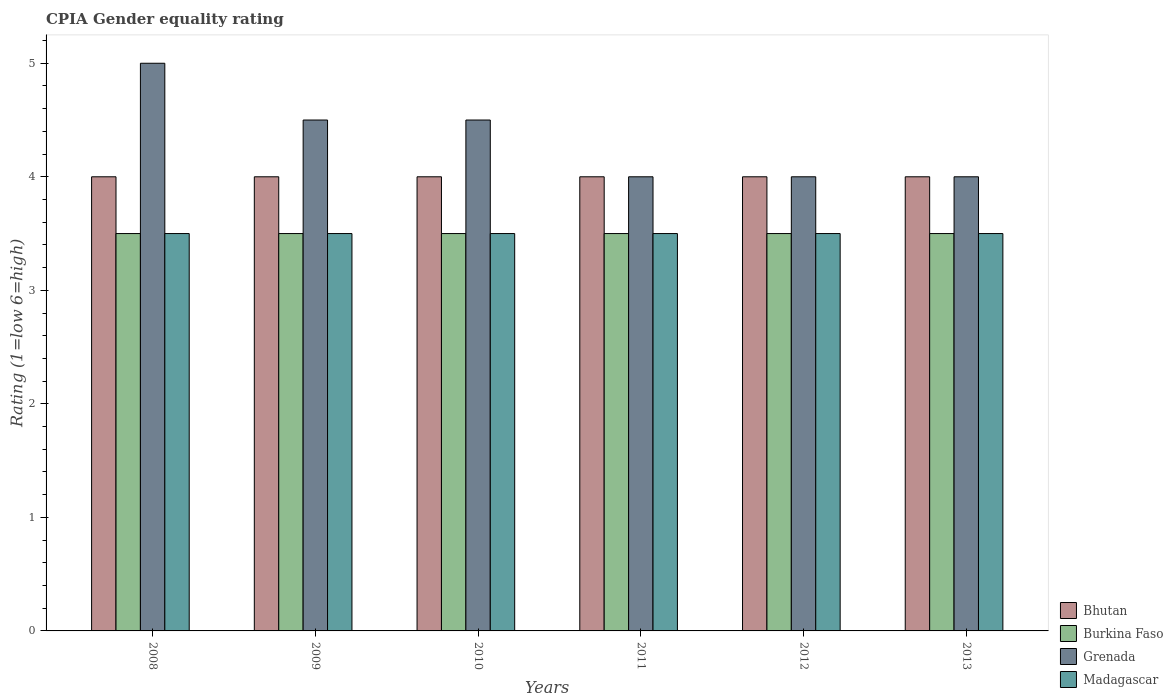Are the number of bars per tick equal to the number of legend labels?
Provide a succinct answer. Yes. Are the number of bars on each tick of the X-axis equal?
Make the answer very short. Yes. How many bars are there on the 2nd tick from the left?
Make the answer very short. 4. How many bars are there on the 3rd tick from the right?
Your response must be concise. 4. Across all years, what is the minimum CPIA rating in Madagascar?
Ensure brevity in your answer.  3.5. What is the difference between the CPIA rating in Grenada in 2008 and that in 2011?
Your response must be concise. 1. What is the average CPIA rating in Grenada per year?
Ensure brevity in your answer.  4.33. In the year 2009, what is the difference between the CPIA rating in Burkina Faso and CPIA rating in Grenada?
Offer a terse response. -1. In how many years, is the CPIA rating in Madagascar greater than 5?
Provide a succinct answer. 0. What is the difference between the highest and the lowest CPIA rating in Grenada?
Provide a short and direct response. 1. Is the sum of the CPIA rating in Madagascar in 2011 and 2013 greater than the maximum CPIA rating in Grenada across all years?
Provide a short and direct response. Yes. Is it the case that in every year, the sum of the CPIA rating in Bhutan and CPIA rating in Grenada is greater than the sum of CPIA rating in Madagascar and CPIA rating in Burkina Faso?
Ensure brevity in your answer.  No. What does the 1st bar from the left in 2008 represents?
Give a very brief answer. Bhutan. What does the 4th bar from the right in 2011 represents?
Keep it short and to the point. Bhutan. Is it the case that in every year, the sum of the CPIA rating in Madagascar and CPIA rating in Bhutan is greater than the CPIA rating in Grenada?
Your answer should be very brief. Yes. What is the title of the graph?
Your answer should be very brief. CPIA Gender equality rating. Does "Tanzania" appear as one of the legend labels in the graph?
Make the answer very short. No. What is the label or title of the X-axis?
Give a very brief answer. Years. What is the Rating (1=low 6=high) of Bhutan in 2008?
Provide a succinct answer. 4. What is the Rating (1=low 6=high) in Burkina Faso in 2008?
Provide a short and direct response. 3.5. What is the Rating (1=low 6=high) of Madagascar in 2008?
Offer a very short reply. 3.5. What is the Rating (1=low 6=high) in Bhutan in 2010?
Provide a succinct answer. 4. What is the Rating (1=low 6=high) in Grenada in 2010?
Your answer should be compact. 4.5. What is the Rating (1=low 6=high) in Grenada in 2011?
Ensure brevity in your answer.  4. What is the Rating (1=low 6=high) of Bhutan in 2013?
Keep it short and to the point. 4. Across all years, what is the maximum Rating (1=low 6=high) in Bhutan?
Provide a short and direct response. 4. Across all years, what is the minimum Rating (1=low 6=high) in Bhutan?
Keep it short and to the point. 4. Across all years, what is the minimum Rating (1=low 6=high) of Madagascar?
Make the answer very short. 3.5. What is the total Rating (1=low 6=high) of Madagascar in the graph?
Your answer should be compact. 21. What is the difference between the Rating (1=low 6=high) of Bhutan in 2008 and that in 2009?
Ensure brevity in your answer.  0. What is the difference between the Rating (1=low 6=high) of Burkina Faso in 2008 and that in 2009?
Your answer should be compact. 0. What is the difference between the Rating (1=low 6=high) of Grenada in 2008 and that in 2009?
Keep it short and to the point. 0.5. What is the difference between the Rating (1=low 6=high) of Madagascar in 2008 and that in 2009?
Your response must be concise. 0. What is the difference between the Rating (1=low 6=high) of Burkina Faso in 2008 and that in 2010?
Offer a terse response. 0. What is the difference between the Rating (1=low 6=high) in Grenada in 2008 and that in 2010?
Provide a short and direct response. 0.5. What is the difference between the Rating (1=low 6=high) in Bhutan in 2008 and that in 2011?
Provide a succinct answer. 0. What is the difference between the Rating (1=low 6=high) of Bhutan in 2008 and that in 2012?
Ensure brevity in your answer.  0. What is the difference between the Rating (1=low 6=high) of Burkina Faso in 2008 and that in 2012?
Provide a succinct answer. 0. What is the difference between the Rating (1=low 6=high) of Grenada in 2008 and that in 2012?
Provide a short and direct response. 1. What is the difference between the Rating (1=low 6=high) of Madagascar in 2008 and that in 2012?
Keep it short and to the point. 0. What is the difference between the Rating (1=low 6=high) in Bhutan in 2009 and that in 2010?
Your answer should be very brief. 0. What is the difference between the Rating (1=low 6=high) of Burkina Faso in 2009 and that in 2010?
Ensure brevity in your answer.  0. What is the difference between the Rating (1=low 6=high) of Madagascar in 2009 and that in 2010?
Your answer should be very brief. 0. What is the difference between the Rating (1=low 6=high) of Burkina Faso in 2009 and that in 2011?
Make the answer very short. 0. What is the difference between the Rating (1=low 6=high) in Grenada in 2009 and that in 2011?
Make the answer very short. 0.5. What is the difference between the Rating (1=low 6=high) in Madagascar in 2009 and that in 2011?
Give a very brief answer. 0. What is the difference between the Rating (1=low 6=high) in Grenada in 2009 and that in 2012?
Make the answer very short. 0.5. What is the difference between the Rating (1=low 6=high) of Madagascar in 2009 and that in 2012?
Make the answer very short. 0. What is the difference between the Rating (1=low 6=high) of Burkina Faso in 2009 and that in 2013?
Offer a very short reply. 0. What is the difference between the Rating (1=low 6=high) in Bhutan in 2010 and that in 2011?
Your answer should be compact. 0. What is the difference between the Rating (1=low 6=high) of Grenada in 2010 and that in 2011?
Provide a short and direct response. 0.5. What is the difference between the Rating (1=low 6=high) of Madagascar in 2010 and that in 2011?
Ensure brevity in your answer.  0. What is the difference between the Rating (1=low 6=high) in Bhutan in 2010 and that in 2012?
Offer a very short reply. 0. What is the difference between the Rating (1=low 6=high) of Grenada in 2010 and that in 2012?
Offer a terse response. 0.5. What is the difference between the Rating (1=low 6=high) in Bhutan in 2010 and that in 2013?
Provide a succinct answer. 0. What is the difference between the Rating (1=low 6=high) in Burkina Faso in 2010 and that in 2013?
Your answer should be very brief. 0. What is the difference between the Rating (1=low 6=high) in Grenada in 2010 and that in 2013?
Ensure brevity in your answer.  0.5. What is the difference between the Rating (1=low 6=high) in Burkina Faso in 2011 and that in 2012?
Your answer should be compact. 0. What is the difference between the Rating (1=low 6=high) of Madagascar in 2011 and that in 2012?
Offer a terse response. 0. What is the difference between the Rating (1=low 6=high) in Burkina Faso in 2011 and that in 2013?
Provide a short and direct response. 0. What is the difference between the Rating (1=low 6=high) of Grenada in 2011 and that in 2013?
Your answer should be compact. 0. What is the difference between the Rating (1=low 6=high) in Madagascar in 2011 and that in 2013?
Your answer should be compact. 0. What is the difference between the Rating (1=low 6=high) of Grenada in 2012 and that in 2013?
Ensure brevity in your answer.  0. What is the difference between the Rating (1=low 6=high) of Bhutan in 2008 and the Rating (1=low 6=high) of Burkina Faso in 2009?
Ensure brevity in your answer.  0.5. What is the difference between the Rating (1=low 6=high) in Bhutan in 2008 and the Rating (1=low 6=high) in Grenada in 2009?
Offer a terse response. -0.5. What is the difference between the Rating (1=low 6=high) in Bhutan in 2008 and the Rating (1=low 6=high) in Madagascar in 2009?
Your response must be concise. 0.5. What is the difference between the Rating (1=low 6=high) of Burkina Faso in 2008 and the Rating (1=low 6=high) of Madagascar in 2009?
Provide a short and direct response. 0. What is the difference between the Rating (1=low 6=high) of Grenada in 2008 and the Rating (1=low 6=high) of Madagascar in 2009?
Your answer should be compact. 1.5. What is the difference between the Rating (1=low 6=high) in Bhutan in 2008 and the Rating (1=low 6=high) in Grenada in 2010?
Keep it short and to the point. -0.5. What is the difference between the Rating (1=low 6=high) of Bhutan in 2008 and the Rating (1=low 6=high) of Madagascar in 2010?
Provide a succinct answer. 0.5. What is the difference between the Rating (1=low 6=high) of Grenada in 2008 and the Rating (1=low 6=high) of Madagascar in 2010?
Make the answer very short. 1.5. What is the difference between the Rating (1=low 6=high) in Bhutan in 2008 and the Rating (1=low 6=high) in Grenada in 2011?
Offer a very short reply. 0. What is the difference between the Rating (1=low 6=high) of Bhutan in 2008 and the Rating (1=low 6=high) of Madagascar in 2011?
Offer a very short reply. 0.5. What is the difference between the Rating (1=low 6=high) of Burkina Faso in 2008 and the Rating (1=low 6=high) of Madagascar in 2011?
Offer a very short reply. 0. What is the difference between the Rating (1=low 6=high) in Grenada in 2008 and the Rating (1=low 6=high) in Madagascar in 2011?
Offer a terse response. 1.5. What is the difference between the Rating (1=low 6=high) in Bhutan in 2008 and the Rating (1=low 6=high) in Madagascar in 2012?
Ensure brevity in your answer.  0.5. What is the difference between the Rating (1=low 6=high) of Burkina Faso in 2008 and the Rating (1=low 6=high) of Madagascar in 2012?
Offer a terse response. 0. What is the difference between the Rating (1=low 6=high) in Bhutan in 2008 and the Rating (1=low 6=high) in Burkina Faso in 2013?
Give a very brief answer. 0.5. What is the difference between the Rating (1=low 6=high) in Bhutan in 2008 and the Rating (1=low 6=high) in Grenada in 2013?
Make the answer very short. 0. What is the difference between the Rating (1=low 6=high) of Bhutan in 2008 and the Rating (1=low 6=high) of Madagascar in 2013?
Offer a very short reply. 0.5. What is the difference between the Rating (1=low 6=high) in Burkina Faso in 2008 and the Rating (1=low 6=high) in Grenada in 2013?
Make the answer very short. -0.5. What is the difference between the Rating (1=low 6=high) of Burkina Faso in 2008 and the Rating (1=low 6=high) of Madagascar in 2013?
Offer a terse response. 0. What is the difference between the Rating (1=low 6=high) of Grenada in 2008 and the Rating (1=low 6=high) of Madagascar in 2013?
Your response must be concise. 1.5. What is the difference between the Rating (1=low 6=high) in Bhutan in 2009 and the Rating (1=low 6=high) in Burkina Faso in 2010?
Your answer should be very brief. 0.5. What is the difference between the Rating (1=low 6=high) of Bhutan in 2009 and the Rating (1=low 6=high) of Grenada in 2010?
Make the answer very short. -0.5. What is the difference between the Rating (1=low 6=high) in Burkina Faso in 2009 and the Rating (1=low 6=high) in Grenada in 2010?
Provide a succinct answer. -1. What is the difference between the Rating (1=low 6=high) of Bhutan in 2009 and the Rating (1=low 6=high) of Burkina Faso in 2011?
Keep it short and to the point. 0.5. What is the difference between the Rating (1=low 6=high) in Bhutan in 2009 and the Rating (1=low 6=high) in Grenada in 2011?
Offer a terse response. 0. What is the difference between the Rating (1=low 6=high) in Bhutan in 2009 and the Rating (1=low 6=high) in Madagascar in 2011?
Provide a succinct answer. 0.5. What is the difference between the Rating (1=low 6=high) in Grenada in 2009 and the Rating (1=low 6=high) in Madagascar in 2011?
Your answer should be compact. 1. What is the difference between the Rating (1=low 6=high) in Bhutan in 2009 and the Rating (1=low 6=high) in Burkina Faso in 2012?
Ensure brevity in your answer.  0.5. What is the difference between the Rating (1=low 6=high) in Bhutan in 2009 and the Rating (1=low 6=high) in Grenada in 2012?
Offer a terse response. 0. What is the difference between the Rating (1=low 6=high) of Burkina Faso in 2009 and the Rating (1=low 6=high) of Grenada in 2012?
Your answer should be compact. -0.5. What is the difference between the Rating (1=low 6=high) of Bhutan in 2009 and the Rating (1=low 6=high) of Burkina Faso in 2013?
Provide a short and direct response. 0.5. What is the difference between the Rating (1=low 6=high) of Bhutan in 2009 and the Rating (1=low 6=high) of Grenada in 2013?
Make the answer very short. 0. What is the difference between the Rating (1=low 6=high) in Burkina Faso in 2009 and the Rating (1=low 6=high) in Grenada in 2013?
Offer a very short reply. -0.5. What is the difference between the Rating (1=low 6=high) of Burkina Faso in 2009 and the Rating (1=low 6=high) of Madagascar in 2013?
Offer a very short reply. 0. What is the difference between the Rating (1=low 6=high) of Grenada in 2009 and the Rating (1=low 6=high) of Madagascar in 2013?
Provide a succinct answer. 1. What is the difference between the Rating (1=low 6=high) of Bhutan in 2010 and the Rating (1=low 6=high) of Grenada in 2011?
Ensure brevity in your answer.  0. What is the difference between the Rating (1=low 6=high) of Bhutan in 2010 and the Rating (1=low 6=high) of Madagascar in 2011?
Ensure brevity in your answer.  0.5. What is the difference between the Rating (1=low 6=high) in Burkina Faso in 2010 and the Rating (1=low 6=high) in Grenada in 2011?
Your answer should be very brief. -0.5. What is the difference between the Rating (1=low 6=high) in Burkina Faso in 2010 and the Rating (1=low 6=high) in Madagascar in 2011?
Provide a succinct answer. 0. What is the difference between the Rating (1=low 6=high) of Grenada in 2010 and the Rating (1=low 6=high) of Madagascar in 2011?
Provide a short and direct response. 1. What is the difference between the Rating (1=low 6=high) of Burkina Faso in 2010 and the Rating (1=low 6=high) of Grenada in 2012?
Provide a succinct answer. -0.5. What is the difference between the Rating (1=low 6=high) of Grenada in 2010 and the Rating (1=low 6=high) of Madagascar in 2012?
Give a very brief answer. 1. What is the difference between the Rating (1=low 6=high) of Bhutan in 2010 and the Rating (1=low 6=high) of Burkina Faso in 2013?
Your response must be concise. 0.5. What is the difference between the Rating (1=low 6=high) of Burkina Faso in 2010 and the Rating (1=low 6=high) of Grenada in 2013?
Provide a short and direct response. -0.5. What is the difference between the Rating (1=low 6=high) in Burkina Faso in 2010 and the Rating (1=low 6=high) in Madagascar in 2013?
Make the answer very short. 0. What is the difference between the Rating (1=low 6=high) in Bhutan in 2011 and the Rating (1=low 6=high) in Grenada in 2012?
Provide a succinct answer. 0. What is the difference between the Rating (1=low 6=high) of Grenada in 2011 and the Rating (1=low 6=high) of Madagascar in 2012?
Make the answer very short. 0.5. What is the difference between the Rating (1=low 6=high) of Bhutan in 2011 and the Rating (1=low 6=high) of Burkina Faso in 2013?
Offer a terse response. 0.5. What is the difference between the Rating (1=low 6=high) in Burkina Faso in 2011 and the Rating (1=low 6=high) in Grenada in 2013?
Give a very brief answer. -0.5. What is the difference between the Rating (1=low 6=high) of Burkina Faso in 2011 and the Rating (1=low 6=high) of Madagascar in 2013?
Give a very brief answer. 0. What is the difference between the Rating (1=low 6=high) of Bhutan in 2012 and the Rating (1=low 6=high) of Burkina Faso in 2013?
Make the answer very short. 0.5. What is the difference between the Rating (1=low 6=high) in Bhutan in 2012 and the Rating (1=low 6=high) in Grenada in 2013?
Provide a short and direct response. 0. What is the difference between the Rating (1=low 6=high) of Burkina Faso in 2012 and the Rating (1=low 6=high) of Madagascar in 2013?
Make the answer very short. 0. What is the difference between the Rating (1=low 6=high) in Grenada in 2012 and the Rating (1=low 6=high) in Madagascar in 2013?
Give a very brief answer. 0.5. What is the average Rating (1=low 6=high) of Grenada per year?
Offer a terse response. 4.33. What is the average Rating (1=low 6=high) of Madagascar per year?
Give a very brief answer. 3.5. In the year 2008, what is the difference between the Rating (1=low 6=high) in Bhutan and Rating (1=low 6=high) in Madagascar?
Your response must be concise. 0.5. In the year 2008, what is the difference between the Rating (1=low 6=high) in Burkina Faso and Rating (1=low 6=high) in Grenada?
Your answer should be very brief. -1.5. In the year 2008, what is the difference between the Rating (1=low 6=high) in Grenada and Rating (1=low 6=high) in Madagascar?
Your response must be concise. 1.5. In the year 2009, what is the difference between the Rating (1=low 6=high) in Bhutan and Rating (1=low 6=high) in Burkina Faso?
Ensure brevity in your answer.  0.5. In the year 2009, what is the difference between the Rating (1=low 6=high) of Burkina Faso and Rating (1=low 6=high) of Madagascar?
Your response must be concise. 0. In the year 2010, what is the difference between the Rating (1=low 6=high) in Bhutan and Rating (1=low 6=high) in Burkina Faso?
Keep it short and to the point. 0.5. In the year 2010, what is the difference between the Rating (1=low 6=high) of Bhutan and Rating (1=low 6=high) of Grenada?
Give a very brief answer. -0.5. In the year 2010, what is the difference between the Rating (1=low 6=high) in Burkina Faso and Rating (1=low 6=high) in Grenada?
Provide a succinct answer. -1. In the year 2011, what is the difference between the Rating (1=low 6=high) of Bhutan and Rating (1=low 6=high) of Madagascar?
Your response must be concise. 0.5. In the year 2011, what is the difference between the Rating (1=low 6=high) of Burkina Faso and Rating (1=low 6=high) of Grenada?
Your answer should be compact. -0.5. In the year 2011, what is the difference between the Rating (1=low 6=high) in Burkina Faso and Rating (1=low 6=high) in Madagascar?
Offer a very short reply. 0. In the year 2011, what is the difference between the Rating (1=low 6=high) of Grenada and Rating (1=low 6=high) of Madagascar?
Provide a succinct answer. 0.5. In the year 2012, what is the difference between the Rating (1=low 6=high) in Bhutan and Rating (1=low 6=high) in Burkina Faso?
Offer a terse response. 0.5. In the year 2012, what is the difference between the Rating (1=low 6=high) of Bhutan and Rating (1=low 6=high) of Grenada?
Provide a succinct answer. 0. In the year 2012, what is the difference between the Rating (1=low 6=high) of Bhutan and Rating (1=low 6=high) of Madagascar?
Ensure brevity in your answer.  0.5. In the year 2012, what is the difference between the Rating (1=low 6=high) in Burkina Faso and Rating (1=low 6=high) in Madagascar?
Ensure brevity in your answer.  0. In the year 2013, what is the difference between the Rating (1=low 6=high) of Bhutan and Rating (1=low 6=high) of Grenada?
Give a very brief answer. 0. In the year 2013, what is the difference between the Rating (1=low 6=high) of Bhutan and Rating (1=low 6=high) of Madagascar?
Provide a short and direct response. 0.5. In the year 2013, what is the difference between the Rating (1=low 6=high) of Burkina Faso and Rating (1=low 6=high) of Madagascar?
Your response must be concise. 0. In the year 2013, what is the difference between the Rating (1=low 6=high) of Grenada and Rating (1=low 6=high) of Madagascar?
Your answer should be compact. 0.5. What is the ratio of the Rating (1=low 6=high) of Grenada in 2008 to that in 2009?
Make the answer very short. 1.11. What is the ratio of the Rating (1=low 6=high) in Grenada in 2008 to that in 2010?
Offer a very short reply. 1.11. What is the ratio of the Rating (1=low 6=high) in Madagascar in 2008 to that in 2010?
Your answer should be very brief. 1. What is the ratio of the Rating (1=low 6=high) in Burkina Faso in 2008 to that in 2011?
Offer a terse response. 1. What is the ratio of the Rating (1=low 6=high) of Madagascar in 2008 to that in 2011?
Your answer should be very brief. 1. What is the ratio of the Rating (1=low 6=high) in Bhutan in 2008 to that in 2012?
Provide a short and direct response. 1. What is the ratio of the Rating (1=low 6=high) in Bhutan in 2008 to that in 2013?
Provide a succinct answer. 1. What is the ratio of the Rating (1=low 6=high) of Burkina Faso in 2008 to that in 2013?
Your response must be concise. 1. What is the ratio of the Rating (1=low 6=high) of Bhutan in 2009 to that in 2010?
Offer a terse response. 1. What is the ratio of the Rating (1=low 6=high) in Burkina Faso in 2009 to that in 2010?
Make the answer very short. 1. What is the ratio of the Rating (1=low 6=high) in Madagascar in 2009 to that in 2010?
Ensure brevity in your answer.  1. What is the ratio of the Rating (1=low 6=high) of Bhutan in 2009 to that in 2011?
Your answer should be compact. 1. What is the ratio of the Rating (1=low 6=high) of Burkina Faso in 2009 to that in 2011?
Offer a very short reply. 1. What is the ratio of the Rating (1=low 6=high) of Madagascar in 2009 to that in 2011?
Your response must be concise. 1. What is the ratio of the Rating (1=low 6=high) in Grenada in 2009 to that in 2012?
Ensure brevity in your answer.  1.12. What is the ratio of the Rating (1=low 6=high) of Burkina Faso in 2009 to that in 2013?
Give a very brief answer. 1. What is the ratio of the Rating (1=low 6=high) in Burkina Faso in 2010 to that in 2011?
Offer a very short reply. 1. What is the ratio of the Rating (1=low 6=high) in Bhutan in 2010 to that in 2012?
Offer a terse response. 1. What is the ratio of the Rating (1=low 6=high) in Grenada in 2010 to that in 2012?
Your answer should be very brief. 1.12. What is the ratio of the Rating (1=low 6=high) of Madagascar in 2010 to that in 2012?
Keep it short and to the point. 1. What is the ratio of the Rating (1=low 6=high) of Bhutan in 2010 to that in 2013?
Ensure brevity in your answer.  1. What is the ratio of the Rating (1=low 6=high) in Burkina Faso in 2010 to that in 2013?
Offer a very short reply. 1. What is the ratio of the Rating (1=low 6=high) in Grenada in 2010 to that in 2013?
Make the answer very short. 1.12. What is the ratio of the Rating (1=low 6=high) of Madagascar in 2010 to that in 2013?
Your answer should be compact. 1. What is the ratio of the Rating (1=low 6=high) in Bhutan in 2011 to that in 2012?
Your response must be concise. 1. What is the ratio of the Rating (1=low 6=high) in Madagascar in 2011 to that in 2012?
Your answer should be compact. 1. What is the ratio of the Rating (1=low 6=high) in Burkina Faso in 2011 to that in 2013?
Give a very brief answer. 1. What is the ratio of the Rating (1=low 6=high) in Grenada in 2011 to that in 2013?
Keep it short and to the point. 1. What is the ratio of the Rating (1=low 6=high) of Burkina Faso in 2012 to that in 2013?
Your response must be concise. 1. What is the ratio of the Rating (1=low 6=high) in Grenada in 2012 to that in 2013?
Give a very brief answer. 1. What is the ratio of the Rating (1=low 6=high) of Madagascar in 2012 to that in 2013?
Keep it short and to the point. 1. What is the difference between the highest and the second highest Rating (1=low 6=high) in Bhutan?
Your answer should be compact. 0. What is the difference between the highest and the second highest Rating (1=low 6=high) of Burkina Faso?
Ensure brevity in your answer.  0. What is the difference between the highest and the second highest Rating (1=low 6=high) in Madagascar?
Make the answer very short. 0. What is the difference between the highest and the lowest Rating (1=low 6=high) in Bhutan?
Make the answer very short. 0. What is the difference between the highest and the lowest Rating (1=low 6=high) of Burkina Faso?
Keep it short and to the point. 0. What is the difference between the highest and the lowest Rating (1=low 6=high) of Madagascar?
Offer a terse response. 0. 